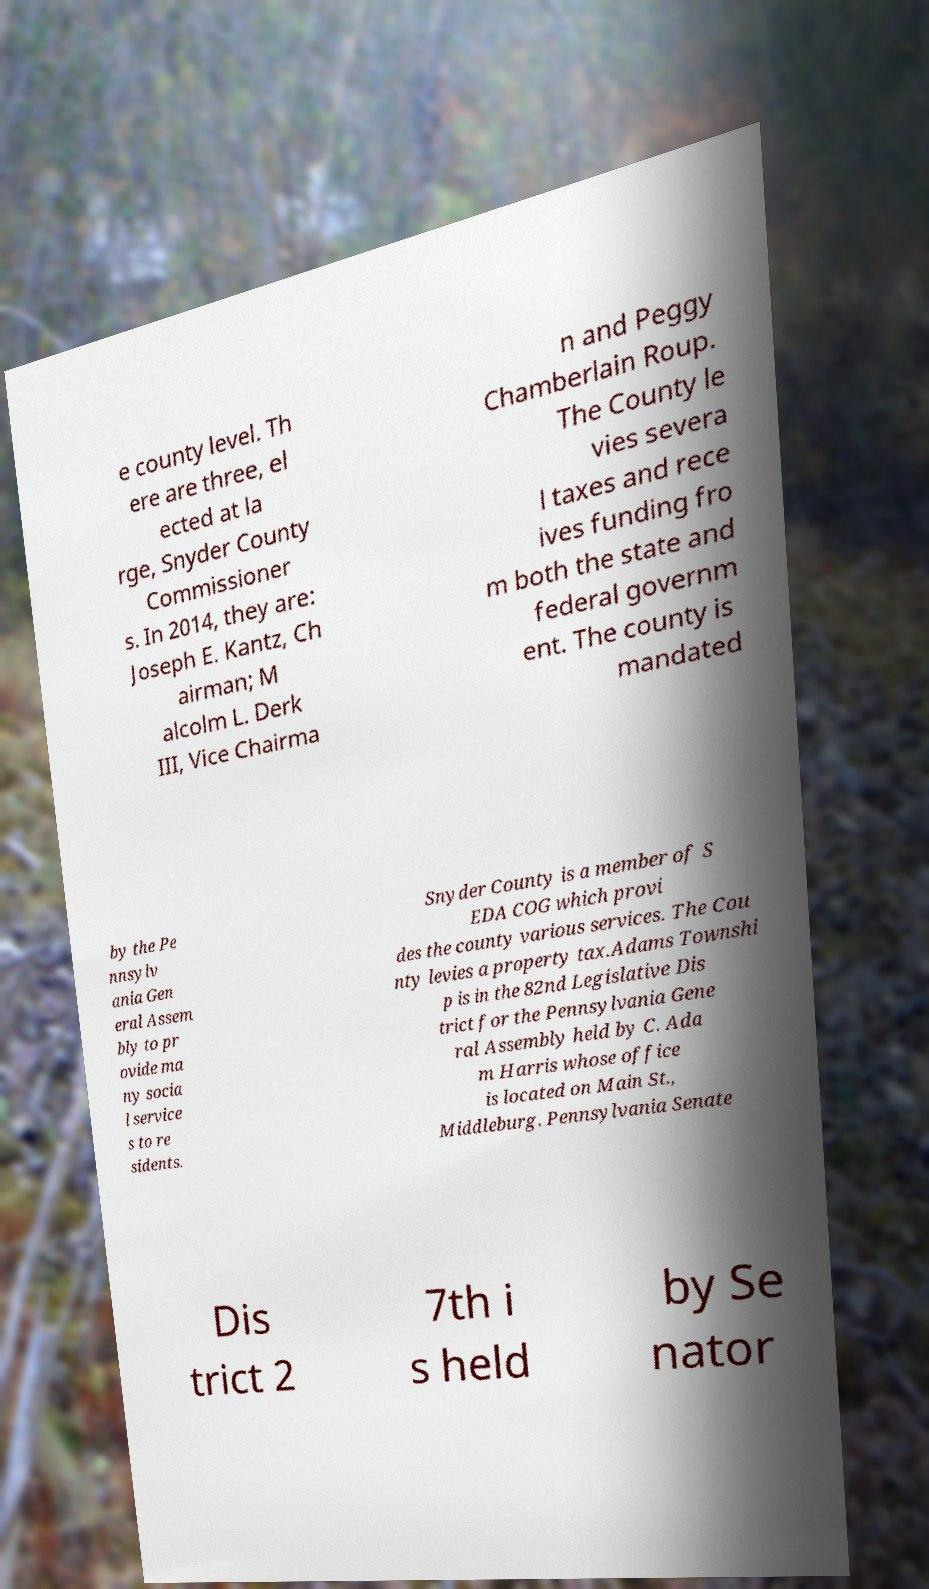Could you assist in decoding the text presented in this image and type it out clearly? e county level. Th ere are three, el ected at la rge, Snyder County Commissioner s. In 2014, they are: Joseph E. Kantz, Ch airman; M alcolm L. Derk III, Vice Chairma n and Peggy Chamberlain Roup. The County le vies severa l taxes and rece ives funding fro m both the state and federal governm ent. The county is mandated by the Pe nnsylv ania Gen eral Assem bly to pr ovide ma ny socia l service s to re sidents. Snyder County is a member of S EDA COG which provi des the county various services. The Cou nty levies a property tax.Adams Townshi p is in the 82nd Legislative Dis trict for the Pennsylvania Gene ral Assembly held by C. Ada m Harris whose office is located on Main St., Middleburg. Pennsylvania Senate Dis trict 2 7th i s held by Se nator 